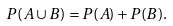<formula> <loc_0><loc_0><loc_500><loc_500>P ( A \cup B ) = P ( A ) + P ( B ) .</formula> 